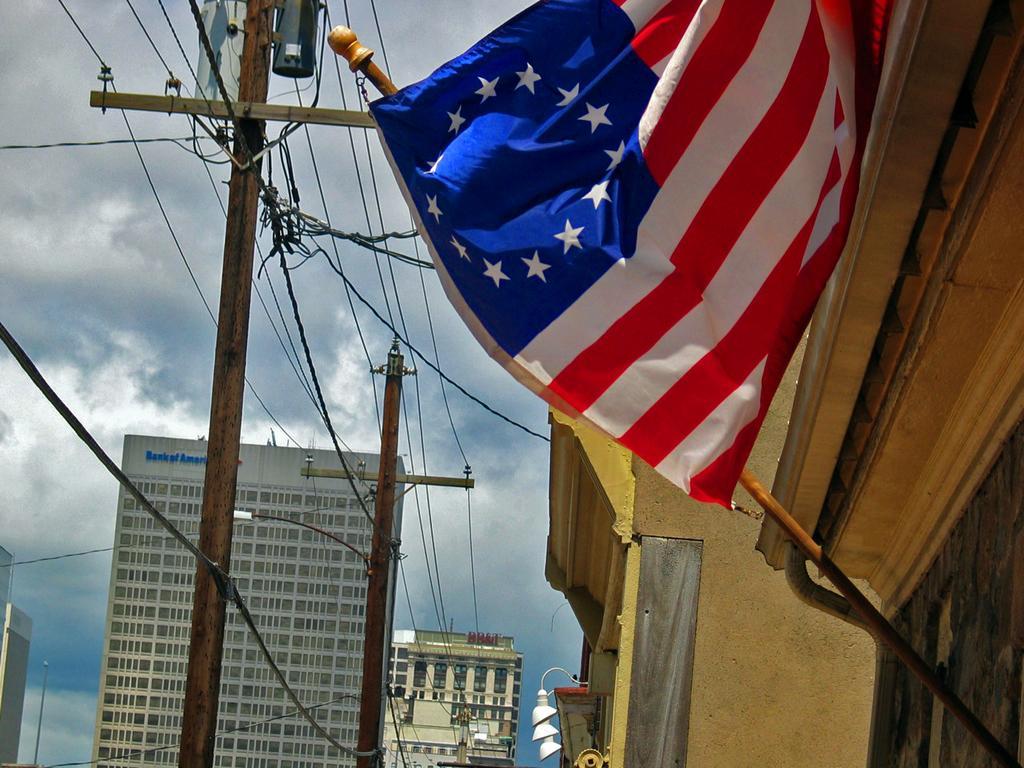In one or two sentences, can you explain what this image depicts? In the image there is a flag to a building on the right side and in front of it there are electric poles, in the background there are buildings and above its sky with clouds. 